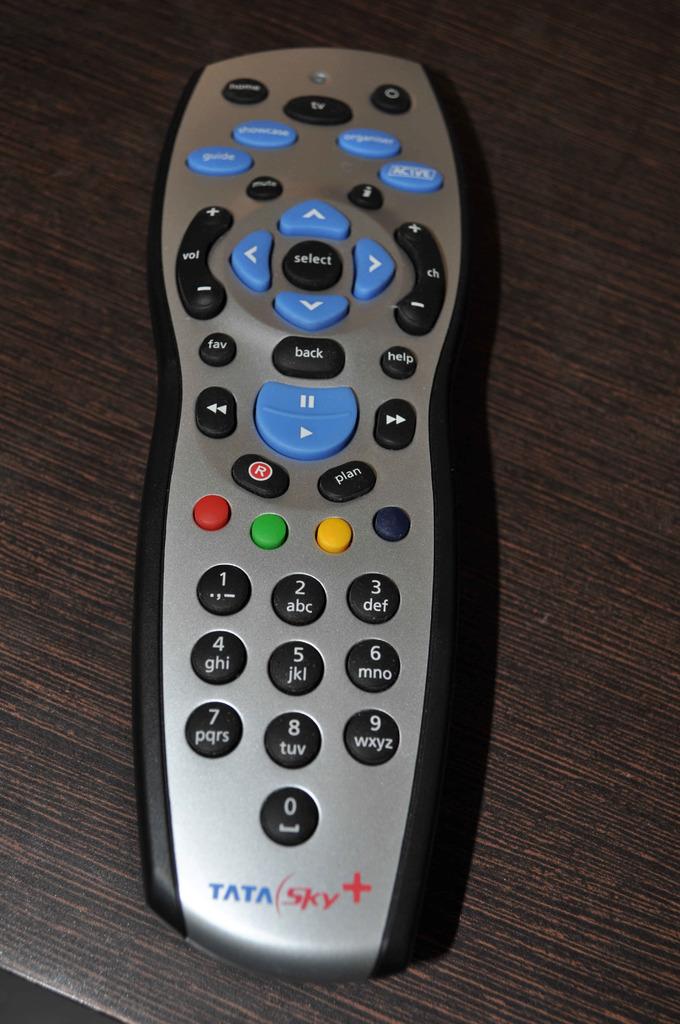What do the blue letters say at the bottom of th remote?
Your answer should be very brief. Tata. What do the red letters at the bottom of the remote say?
Provide a short and direct response. Sky. 